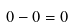Convert formula to latex. <formula><loc_0><loc_0><loc_500><loc_500>0 - 0 = 0</formula> 